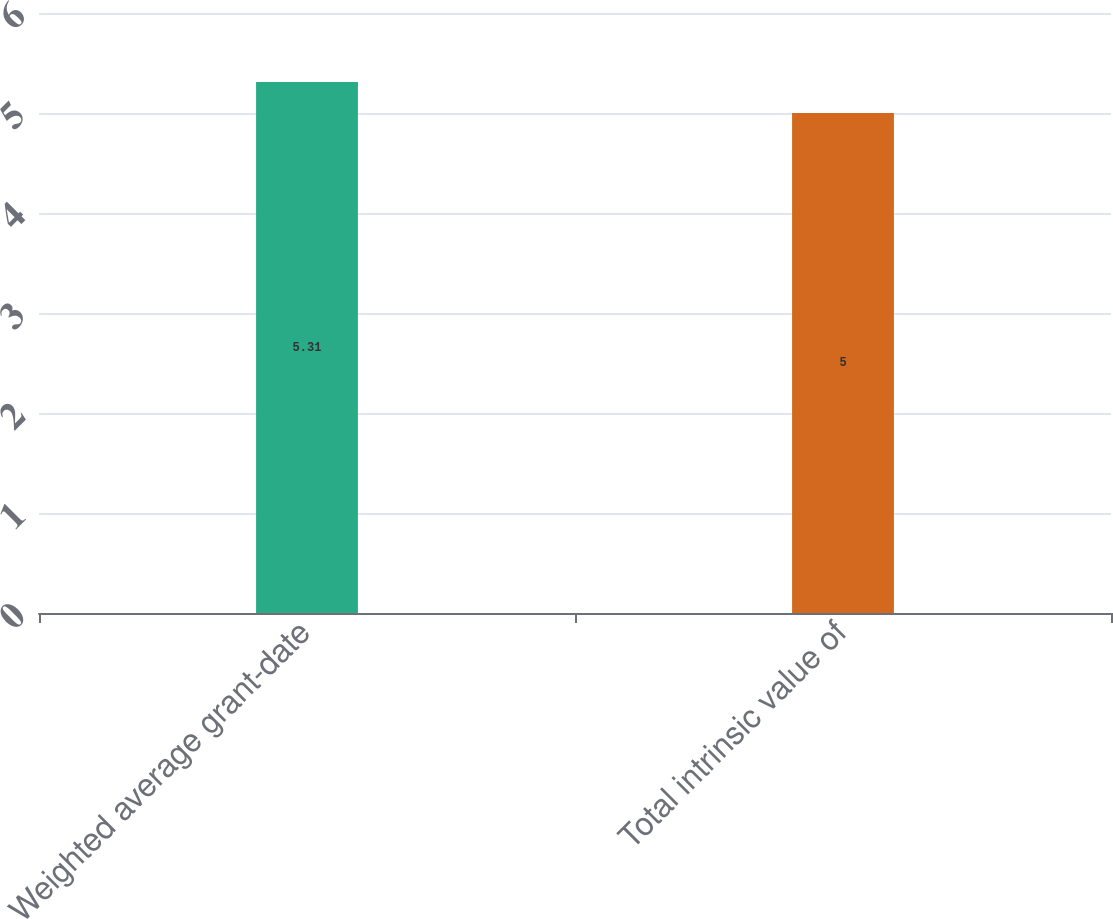Convert chart to OTSL. <chart><loc_0><loc_0><loc_500><loc_500><bar_chart><fcel>Weighted average grant-date<fcel>Total intrinsic value of<nl><fcel>5.31<fcel>5<nl></chart> 